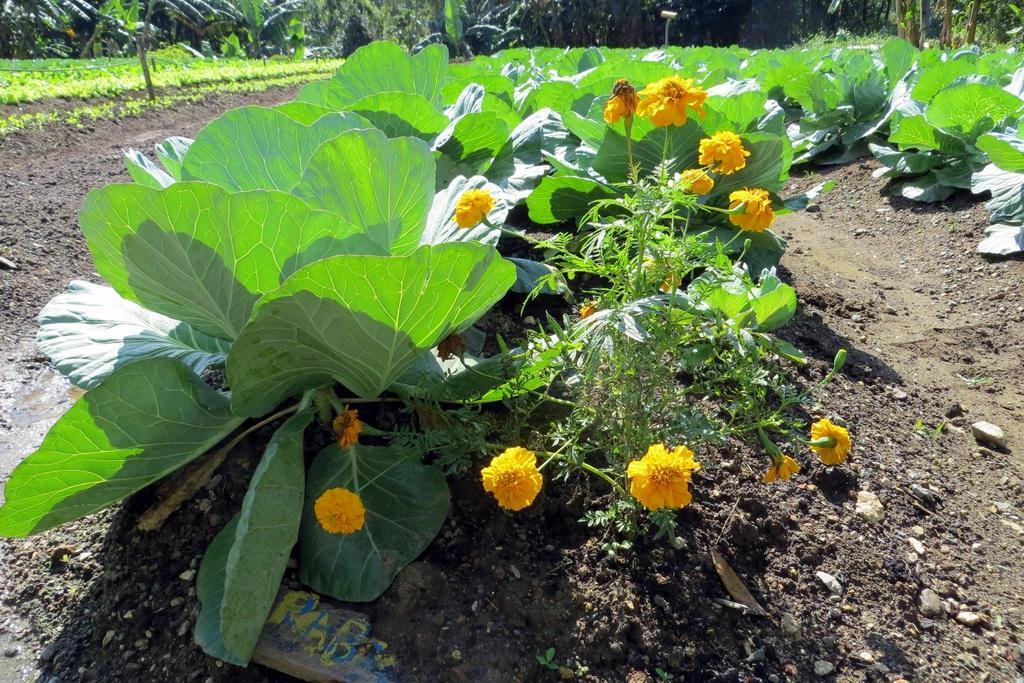In one or two sentences, can you explain what this image depicts? There is a plant with flowers. Also there are other plants. In the background there are trees. On the ground there is soil and stones. 